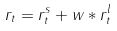Convert formula to latex. <formula><loc_0><loc_0><loc_500><loc_500>r _ { t } = r _ { t } ^ { s } + w * r _ { t } ^ { l }</formula> 